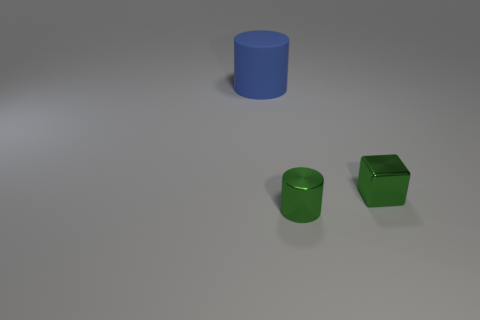Add 1 large blue rubber cylinders. How many objects exist? 4 Subtract all cubes. How many objects are left? 2 Subtract all small blue spheres. Subtract all green blocks. How many objects are left? 2 Add 1 tiny green shiny cylinders. How many tiny green shiny cylinders are left? 2 Add 2 large cylinders. How many large cylinders exist? 3 Subtract 0 gray cylinders. How many objects are left? 3 